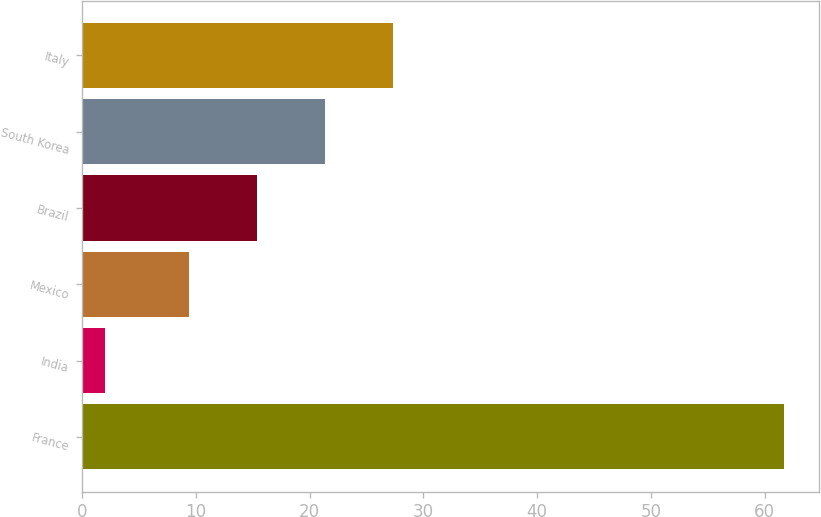Convert chart to OTSL. <chart><loc_0><loc_0><loc_500><loc_500><bar_chart><fcel>France<fcel>India<fcel>Mexico<fcel>Brazil<fcel>South Korea<fcel>Italy<nl><fcel>61.7<fcel>2<fcel>9.4<fcel>15.37<fcel>21.34<fcel>27.31<nl></chart> 